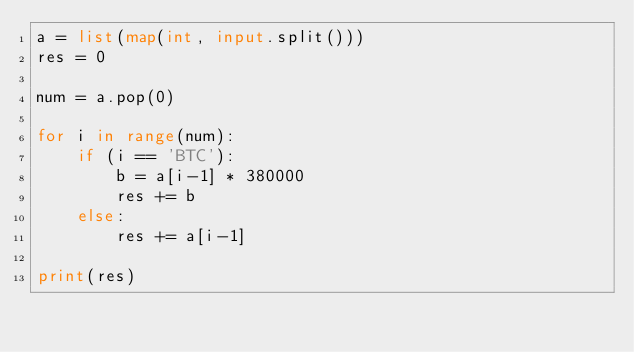Convert code to text. <code><loc_0><loc_0><loc_500><loc_500><_Python_>a = list(map(int, input.split()))
res = 0

num = a.pop(0)

for i in range(num):
    if (i == 'BTC'):
        b = a[i-1] * 380000
        res += b
    else:
        res += a[i-1]

print(res) </code> 